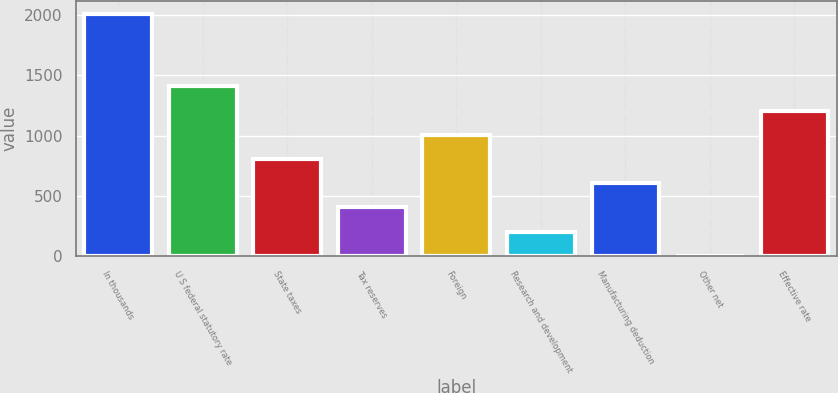<chart> <loc_0><loc_0><loc_500><loc_500><bar_chart><fcel>In thousands<fcel>U S federal statutory rate<fcel>State taxes<fcel>Tax reserves<fcel>Foreign<fcel>Research and development<fcel>Manufacturing deduction<fcel>Other net<fcel>Effective rate<nl><fcel>2013<fcel>1409.22<fcel>805.44<fcel>402.92<fcel>1006.7<fcel>201.66<fcel>604.18<fcel>0.4<fcel>1207.96<nl></chart> 